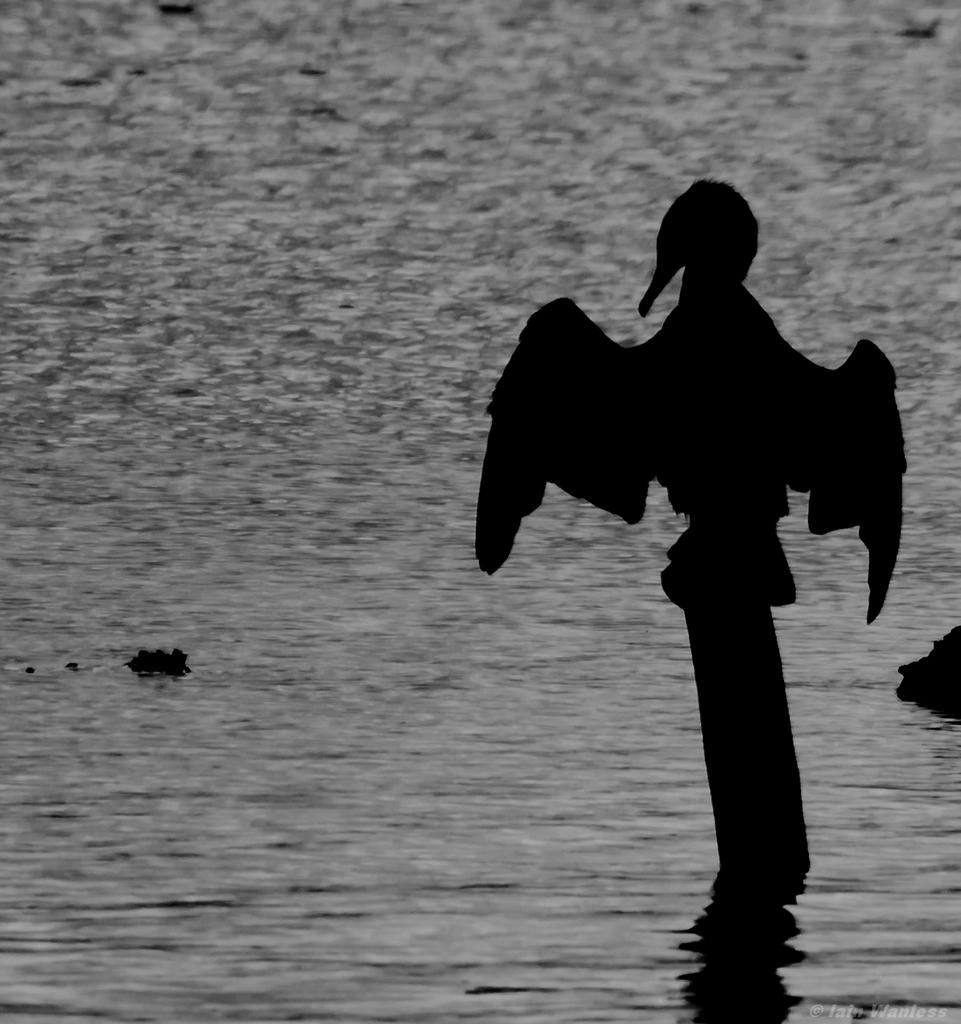What is the color scheme of the image? The image is black and white. What type of animal can be seen in the image? There is a bird in the image. Where is the bird located in the image? The bird is on a pole. What is the pole situated in? The pole is in the water. How many slaves are visible in the image? There are no slaves present in the image. What type of footwear is the bird wearing in the image? Birds do not wear footwear, and there is no indication of any footwear in the image. 